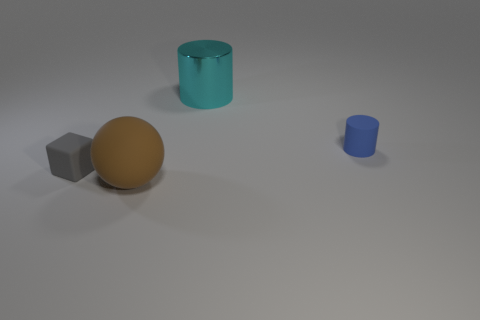There is a object that is behind the gray cube and to the left of the tiny cylinder; what material is it? The object behind the gray cube and to the left of the tiny cylinder appears to have a shiny, reflective surface suggesting it could be made of a polished metal. 